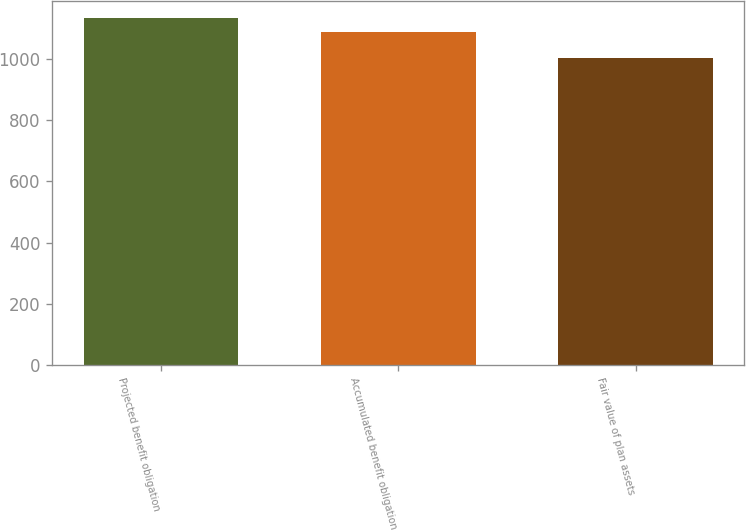Convert chart. <chart><loc_0><loc_0><loc_500><loc_500><bar_chart><fcel>Projected benefit obligation<fcel>Accumulated benefit obligation<fcel>Fair value of plan assets<nl><fcel>1134<fcel>1088<fcel>1004<nl></chart> 